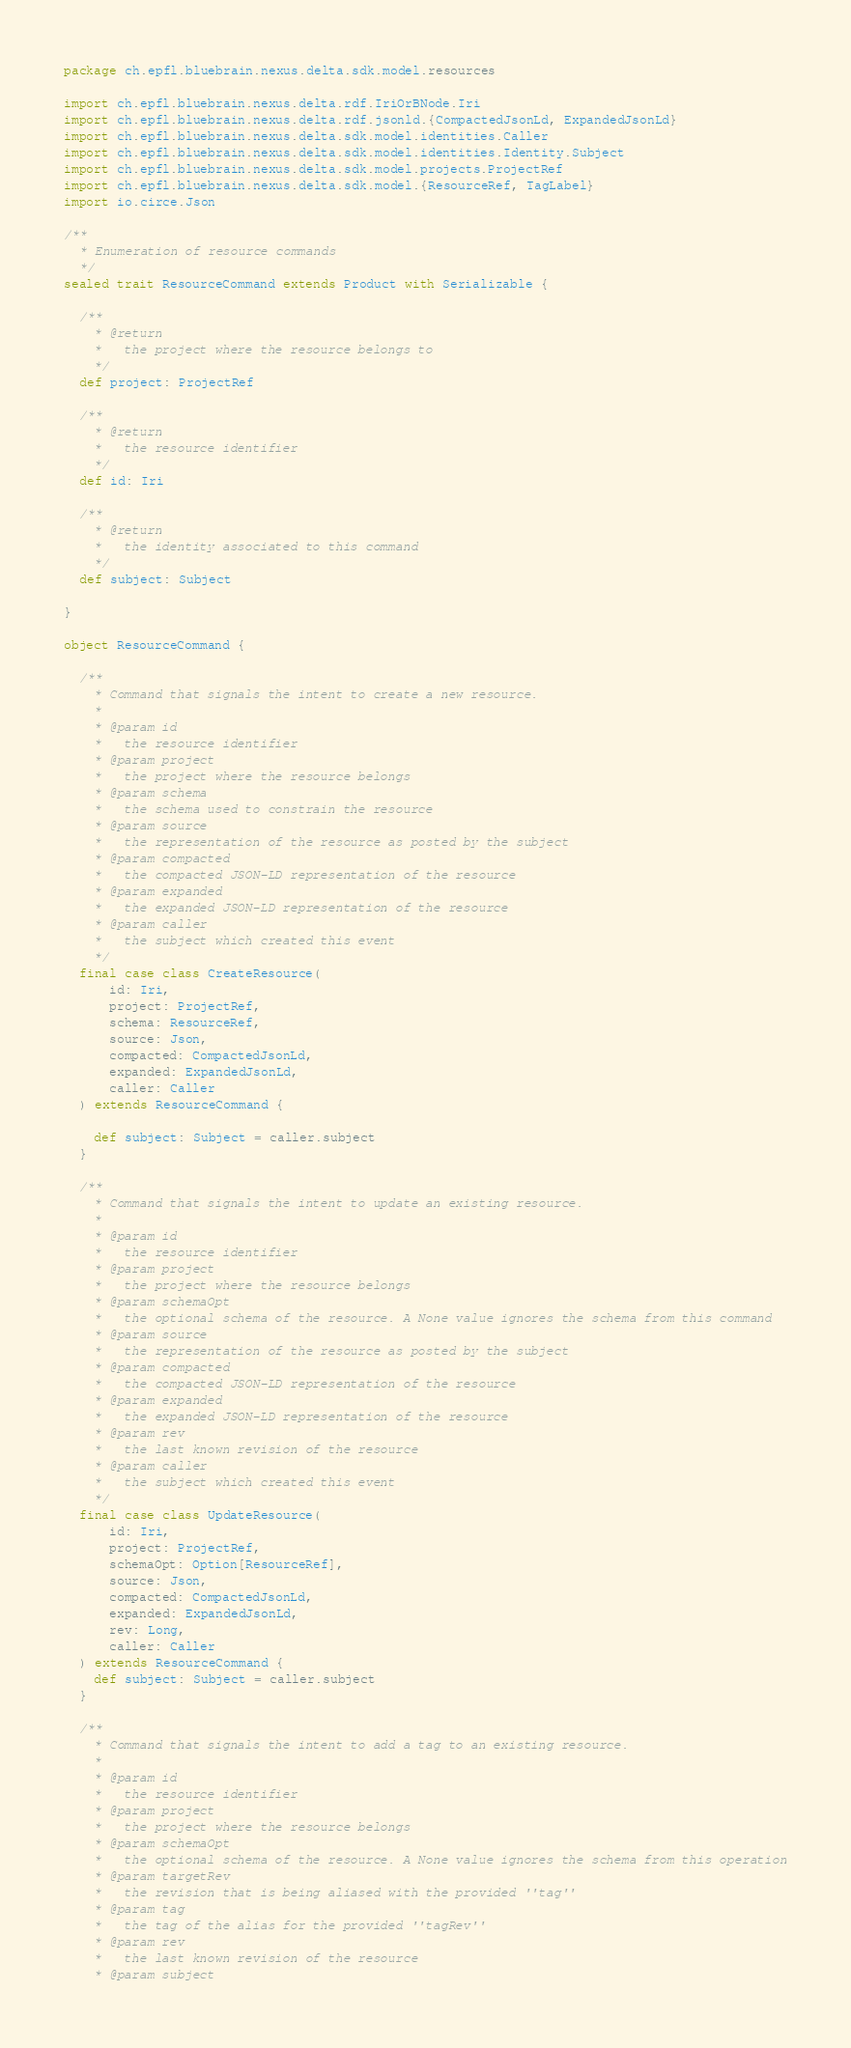Convert code to text. <code><loc_0><loc_0><loc_500><loc_500><_Scala_>package ch.epfl.bluebrain.nexus.delta.sdk.model.resources

import ch.epfl.bluebrain.nexus.delta.rdf.IriOrBNode.Iri
import ch.epfl.bluebrain.nexus.delta.rdf.jsonld.{CompactedJsonLd, ExpandedJsonLd}
import ch.epfl.bluebrain.nexus.delta.sdk.model.identities.Caller
import ch.epfl.bluebrain.nexus.delta.sdk.model.identities.Identity.Subject
import ch.epfl.bluebrain.nexus.delta.sdk.model.projects.ProjectRef
import ch.epfl.bluebrain.nexus.delta.sdk.model.{ResourceRef, TagLabel}
import io.circe.Json

/**
  * Enumeration of resource commands
  */
sealed trait ResourceCommand extends Product with Serializable {

  /**
    * @return
    *   the project where the resource belongs to
    */
  def project: ProjectRef

  /**
    * @return
    *   the resource identifier
    */
  def id: Iri

  /**
    * @return
    *   the identity associated to this command
    */
  def subject: Subject

}

object ResourceCommand {

  /**
    * Command that signals the intent to create a new resource.
    *
    * @param id
    *   the resource identifier
    * @param project
    *   the project where the resource belongs
    * @param schema
    *   the schema used to constrain the resource
    * @param source
    *   the representation of the resource as posted by the subject
    * @param compacted
    *   the compacted JSON-LD representation of the resource
    * @param expanded
    *   the expanded JSON-LD representation of the resource
    * @param caller
    *   the subject which created this event
    */
  final case class CreateResource(
      id: Iri,
      project: ProjectRef,
      schema: ResourceRef,
      source: Json,
      compacted: CompactedJsonLd,
      expanded: ExpandedJsonLd,
      caller: Caller
  ) extends ResourceCommand {

    def subject: Subject = caller.subject
  }

  /**
    * Command that signals the intent to update an existing resource.
    *
    * @param id
    *   the resource identifier
    * @param project
    *   the project where the resource belongs
    * @param schemaOpt
    *   the optional schema of the resource. A None value ignores the schema from this command
    * @param source
    *   the representation of the resource as posted by the subject
    * @param compacted
    *   the compacted JSON-LD representation of the resource
    * @param expanded
    *   the expanded JSON-LD representation of the resource
    * @param rev
    *   the last known revision of the resource
    * @param caller
    *   the subject which created this event
    */
  final case class UpdateResource(
      id: Iri,
      project: ProjectRef,
      schemaOpt: Option[ResourceRef],
      source: Json,
      compacted: CompactedJsonLd,
      expanded: ExpandedJsonLd,
      rev: Long,
      caller: Caller
  ) extends ResourceCommand {
    def subject: Subject = caller.subject
  }

  /**
    * Command that signals the intent to add a tag to an existing resource.
    *
    * @param id
    *   the resource identifier
    * @param project
    *   the project where the resource belongs
    * @param schemaOpt
    *   the optional schema of the resource. A None value ignores the schema from this operation
    * @param targetRev
    *   the revision that is being aliased with the provided ''tag''
    * @param tag
    *   the tag of the alias for the provided ''tagRev''
    * @param rev
    *   the last known revision of the resource
    * @param subject</code> 